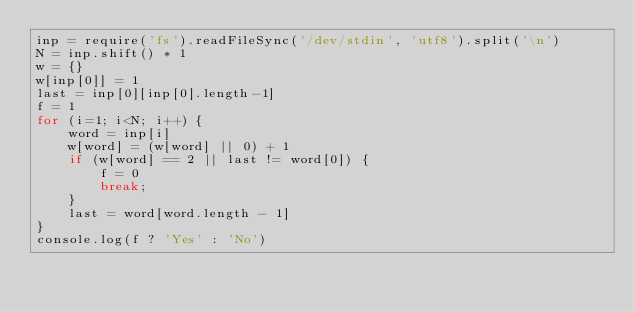Convert code to text. <code><loc_0><loc_0><loc_500><loc_500><_JavaScript_>inp = require('fs').readFileSync('/dev/stdin', 'utf8').split('\n')
N = inp.shift() * 1
w = {}
w[inp[0]] = 1
last = inp[0][inp[0].length-1]
f = 1
for (i=1; i<N; i++) {
    word = inp[i]
    w[word] = (w[word] || 0) + 1
    if (w[word] == 2 || last != word[0]) {
        f = 0
        break;
    }
    last = word[word.length - 1]
}
console.log(f ? 'Yes' : 'No')</code> 